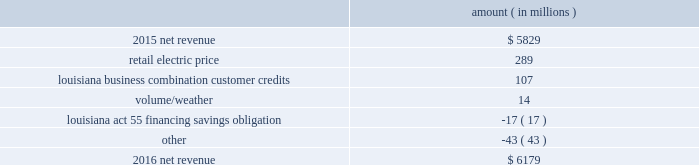Entergy corporation and subsidiaries management 2019s financial discussion and analysis palisades plants and related assets to their fair values .
See note 14 to the financial statements for further discussion of the impairment and related charges .
As a result of the entergy louisiana and entergy gulf states louisiana business combination , results of operations for 2015 also include two items that occurred in october 2015 : 1 ) a deferred tax asset and resulting net increase in tax basis of approximately $ 334 million and 2 ) a regulatory liability of $ 107 million ( $ 66 million net-of-tax ) as a result of customer credits to be realized by electric customers of entergy louisiana , consistent with the terms of the stipulated settlement in the business combination proceeding .
See note 2 to the financial statements for further discussion of the business combination and customer credits .
Results of operations for 2015 also include the sale in december 2015 of the 583 mw rhode island state energy center for a realized gain of $ 154 million ( $ 100 million net-of-tax ) on the sale and the $ 77 million ( $ 47 million net-of-tax ) write-off and regulatory charges to recognize that a portion of the assets associated with the waterford 3 replacement steam generator project is no longer probable of recovery .
See note 14 to the financial statements for further discussion of the rhode island state energy center sale .
See note 2 to the financial statements for further discussion of the waterford 3 write-off .
Net revenue utility following is an analysis of the change in net revenue comparing 2016 to 2015 .
Amount ( in millions ) .
The retail electric price variance is primarily due to : 2022 an increase in base rates at entergy arkansas , as approved by the apsc .
The new rates were effective february 24 , 2016 and began billing with the first billing cycle of april 2016 .
The increase includes an interim base rate adjustment surcharge , effective with the first billing cycle of april 2016 , to recover the incremental revenue requirement for the period february 24 , 2016 through march 31 , 2016 .
A significant portion of the increase is related to the purchase of power block 2 of the union power station ; 2022 an increase in the purchased power and capacity acquisition cost recovery rider for entergy new orleans , as approved by the city council , effective with the first billing cycle of march 2016 , primarily related to the purchase of power block 1 of the union power station ; 2022 an increase in formula rate plan revenues for entergy louisiana , implemented with the first billing cycle of march 2016 , to collect the estimated first-year revenue requirement related to the purchase of power blocks 3 and 4 of the union power station ; and 2022 an increase in revenues at entergy mississippi , as approved by the mpsc , effective with the first billing cycle of july 2016 , and an increase in revenues collected through the storm damage rider .
See note 2 to the financial statements for further discussion of the rate proceedings .
See note 14 to the financial statements for discussion of the union power station purchase .
The louisiana business combination customer credits variance is due to a regulatory liability of $ 107 million recorded by entergy in october 2015 as a result of the entergy gulf states louisiana and entergy louisiana business .
What portion of the net change in net revenue is due to retail electric price? 
Computations: (289 / (6179 - 5829))
Answer: 0.82571. Entergy corporation and subsidiaries management 2019s financial discussion and analysis palisades plants and related assets to their fair values .
See note 14 to the financial statements for further discussion of the impairment and related charges .
As a result of the entergy louisiana and entergy gulf states louisiana business combination , results of operations for 2015 also include two items that occurred in october 2015 : 1 ) a deferred tax asset and resulting net increase in tax basis of approximately $ 334 million and 2 ) a regulatory liability of $ 107 million ( $ 66 million net-of-tax ) as a result of customer credits to be realized by electric customers of entergy louisiana , consistent with the terms of the stipulated settlement in the business combination proceeding .
See note 2 to the financial statements for further discussion of the business combination and customer credits .
Results of operations for 2015 also include the sale in december 2015 of the 583 mw rhode island state energy center for a realized gain of $ 154 million ( $ 100 million net-of-tax ) on the sale and the $ 77 million ( $ 47 million net-of-tax ) write-off and regulatory charges to recognize that a portion of the assets associated with the waterford 3 replacement steam generator project is no longer probable of recovery .
See note 14 to the financial statements for further discussion of the rhode island state energy center sale .
See note 2 to the financial statements for further discussion of the waterford 3 write-off .
Net revenue utility following is an analysis of the change in net revenue comparing 2016 to 2015 .
Amount ( in millions ) .
The retail electric price variance is primarily due to : 2022 an increase in base rates at entergy arkansas , as approved by the apsc .
The new rates were effective february 24 , 2016 and began billing with the first billing cycle of april 2016 .
The increase includes an interim base rate adjustment surcharge , effective with the first billing cycle of april 2016 , to recover the incremental revenue requirement for the period february 24 , 2016 through march 31 , 2016 .
A significant portion of the increase is related to the purchase of power block 2 of the union power station ; 2022 an increase in the purchased power and capacity acquisition cost recovery rider for entergy new orleans , as approved by the city council , effective with the first billing cycle of march 2016 , primarily related to the purchase of power block 1 of the union power station ; 2022 an increase in formula rate plan revenues for entergy louisiana , implemented with the first billing cycle of march 2016 , to collect the estimated first-year revenue requirement related to the purchase of power blocks 3 and 4 of the union power station ; and 2022 an increase in revenues at entergy mississippi , as approved by the mpsc , effective with the first billing cycle of july 2016 , and an increase in revenues collected through the storm damage rider .
See note 2 to the financial statements for further discussion of the rate proceedings .
See note 14 to the financial statements for discussion of the union power station purchase .
The louisiana business combination customer credits variance is due to a regulatory liability of $ 107 million recorded by entergy in october 2015 as a result of the entergy gulf states louisiana and entergy louisiana business .
What is the growth rate in net revenue in 2016? 
Computations: ((6179 - 5829) / 5829)
Answer: 0.06004. 